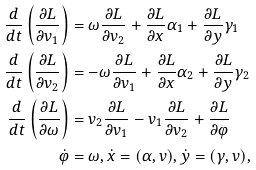Convert formula to latex. <formula><loc_0><loc_0><loc_500><loc_500>\frac { d } { d t } \left ( { \frac { \partial L } { \partial v _ { 1 } } } \right ) & = \omega { \frac { \partial L } { \partial v _ { 2 } } } + { \frac { \partial L } { \partial x } } \alpha _ { 1 } + { \frac { \partial L } { \partial y } } \gamma _ { 1 } \\ \frac { d } { d t } \left ( { \frac { \partial L } { \partial v _ { 2 } } } \right ) & = - \omega { \frac { \partial L } { \partial v _ { 1 } } } + { \frac { \partial L } { \partial x } } \alpha _ { 2 } + { \frac { \partial L } { \partial y } } \gamma _ { 2 } \\ \frac { d } { d t } \left ( { \frac { \partial L } { \partial \omega } } \right ) & = v _ { 2 } { \frac { \partial L } { \partial v _ { 1 } } } - v _ { 1 } { \frac { \partial L } { \partial v _ { 2 } } } + { \frac { \partial L } { \partial { \varphi } } } \\ \dot { \varphi } & = \omega , \dot { x } = ( \alpha , v ) , \dot { y } = ( \gamma , v ) ,</formula> 